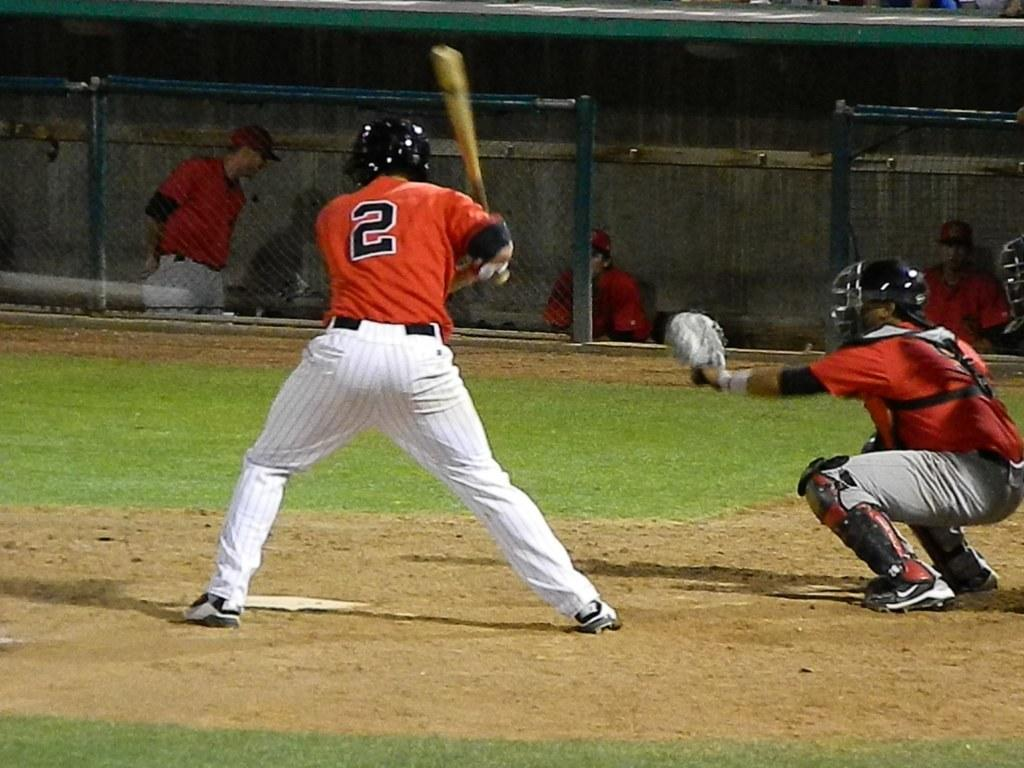<image>
Share a concise interpretation of the image provided. Baseball player wearing number 2 about to bat the ball. 